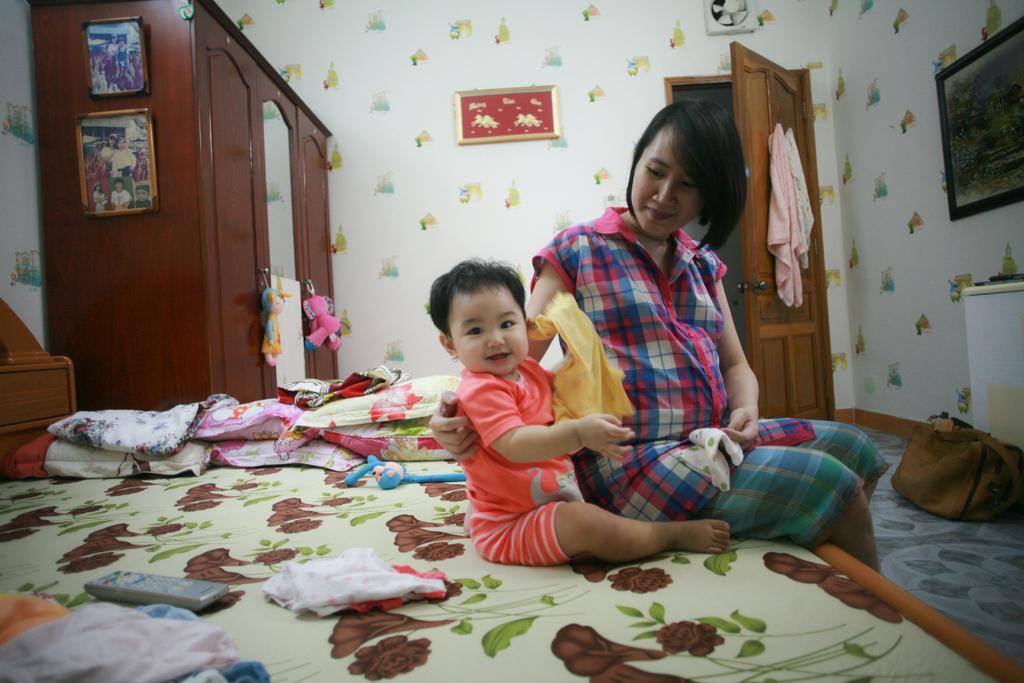Can you describe this image briefly? As we can see in the image there is a white color wall, photo frame, door, cloth, almirah, mirror and a girl and child sitting on bed. On bed there is a remote and pillows. 